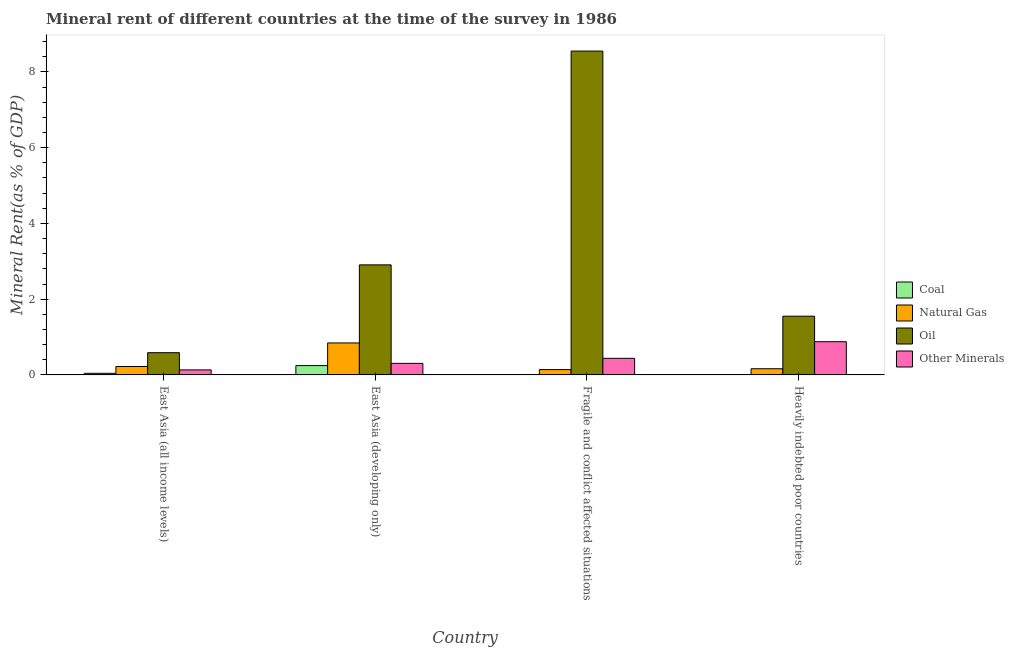Are the number of bars per tick equal to the number of legend labels?
Keep it short and to the point. Yes. Are the number of bars on each tick of the X-axis equal?
Your answer should be compact. Yes. How many bars are there on the 3rd tick from the left?
Provide a succinct answer. 4. How many bars are there on the 4th tick from the right?
Make the answer very short. 4. What is the label of the 4th group of bars from the left?
Your response must be concise. Heavily indebted poor countries. In how many cases, is the number of bars for a given country not equal to the number of legend labels?
Give a very brief answer. 0. What is the  rent of other minerals in Heavily indebted poor countries?
Give a very brief answer. 0.88. Across all countries, what is the maximum  rent of other minerals?
Keep it short and to the point. 0.88. Across all countries, what is the minimum oil rent?
Offer a terse response. 0.59. In which country was the oil rent maximum?
Your answer should be very brief. Fragile and conflict affected situations. In which country was the coal rent minimum?
Provide a short and direct response. Heavily indebted poor countries. What is the total  rent of other minerals in the graph?
Give a very brief answer. 1.75. What is the difference between the coal rent in East Asia (all income levels) and that in Heavily indebted poor countries?
Make the answer very short. 0.04. What is the difference between the  rent of other minerals in East Asia (all income levels) and the oil rent in Heavily indebted poor countries?
Make the answer very short. -1.42. What is the average oil rent per country?
Offer a terse response. 3.4. What is the difference between the natural gas rent and coal rent in Fragile and conflict affected situations?
Keep it short and to the point. 0.13. What is the ratio of the natural gas rent in East Asia (developing only) to that in Heavily indebted poor countries?
Keep it short and to the point. 5.18. Is the  rent of other minerals in East Asia (all income levels) less than that in Heavily indebted poor countries?
Offer a terse response. Yes. What is the difference between the highest and the second highest oil rent?
Your answer should be very brief. 5.64. What is the difference between the highest and the lowest coal rent?
Provide a succinct answer. 0.24. Is it the case that in every country, the sum of the oil rent and coal rent is greater than the sum of natural gas rent and  rent of other minerals?
Ensure brevity in your answer.  Yes. What does the 1st bar from the left in East Asia (developing only) represents?
Offer a terse response. Coal. What does the 1st bar from the right in Fragile and conflict affected situations represents?
Provide a succinct answer. Other Minerals. Are all the bars in the graph horizontal?
Give a very brief answer. No. Where does the legend appear in the graph?
Offer a terse response. Center right. How many legend labels are there?
Offer a very short reply. 4. What is the title of the graph?
Keep it short and to the point. Mineral rent of different countries at the time of the survey in 1986. Does "Secondary general education" appear as one of the legend labels in the graph?
Offer a very short reply. No. What is the label or title of the Y-axis?
Your answer should be very brief. Mineral Rent(as % of GDP). What is the Mineral Rent(as % of GDP) in Coal in East Asia (all income levels)?
Offer a terse response. 0.04. What is the Mineral Rent(as % of GDP) of Natural Gas in East Asia (all income levels)?
Keep it short and to the point. 0.22. What is the Mineral Rent(as % of GDP) in Oil in East Asia (all income levels)?
Provide a short and direct response. 0.59. What is the Mineral Rent(as % of GDP) in Other Minerals in East Asia (all income levels)?
Make the answer very short. 0.13. What is the Mineral Rent(as % of GDP) in Coal in East Asia (developing only)?
Give a very brief answer. 0.25. What is the Mineral Rent(as % of GDP) in Natural Gas in East Asia (developing only)?
Ensure brevity in your answer.  0.84. What is the Mineral Rent(as % of GDP) of Oil in East Asia (developing only)?
Your response must be concise. 2.91. What is the Mineral Rent(as % of GDP) of Other Minerals in East Asia (developing only)?
Your answer should be compact. 0.3. What is the Mineral Rent(as % of GDP) of Coal in Fragile and conflict affected situations?
Offer a very short reply. 0.01. What is the Mineral Rent(as % of GDP) of Natural Gas in Fragile and conflict affected situations?
Provide a short and direct response. 0.14. What is the Mineral Rent(as % of GDP) of Oil in Fragile and conflict affected situations?
Offer a very short reply. 8.55. What is the Mineral Rent(as % of GDP) in Other Minerals in Fragile and conflict affected situations?
Offer a terse response. 0.44. What is the Mineral Rent(as % of GDP) of Coal in Heavily indebted poor countries?
Your response must be concise. 0. What is the Mineral Rent(as % of GDP) in Natural Gas in Heavily indebted poor countries?
Provide a succinct answer. 0.16. What is the Mineral Rent(as % of GDP) of Oil in Heavily indebted poor countries?
Provide a short and direct response. 1.55. What is the Mineral Rent(as % of GDP) of Other Minerals in Heavily indebted poor countries?
Keep it short and to the point. 0.88. Across all countries, what is the maximum Mineral Rent(as % of GDP) of Coal?
Your response must be concise. 0.25. Across all countries, what is the maximum Mineral Rent(as % of GDP) in Natural Gas?
Offer a very short reply. 0.84. Across all countries, what is the maximum Mineral Rent(as % of GDP) of Oil?
Keep it short and to the point. 8.55. Across all countries, what is the maximum Mineral Rent(as % of GDP) in Other Minerals?
Make the answer very short. 0.88. Across all countries, what is the minimum Mineral Rent(as % of GDP) in Coal?
Provide a short and direct response. 0. Across all countries, what is the minimum Mineral Rent(as % of GDP) in Natural Gas?
Keep it short and to the point. 0.14. Across all countries, what is the minimum Mineral Rent(as % of GDP) in Oil?
Provide a succinct answer. 0.59. Across all countries, what is the minimum Mineral Rent(as % of GDP) of Other Minerals?
Give a very brief answer. 0.13. What is the total Mineral Rent(as % of GDP) of Coal in the graph?
Provide a succinct answer. 0.3. What is the total Mineral Rent(as % of GDP) in Natural Gas in the graph?
Offer a terse response. 1.37. What is the total Mineral Rent(as % of GDP) of Oil in the graph?
Provide a succinct answer. 13.59. What is the total Mineral Rent(as % of GDP) in Other Minerals in the graph?
Provide a succinct answer. 1.75. What is the difference between the Mineral Rent(as % of GDP) of Coal in East Asia (all income levels) and that in East Asia (developing only)?
Offer a terse response. -0.2. What is the difference between the Mineral Rent(as % of GDP) of Natural Gas in East Asia (all income levels) and that in East Asia (developing only)?
Give a very brief answer. -0.62. What is the difference between the Mineral Rent(as % of GDP) in Oil in East Asia (all income levels) and that in East Asia (developing only)?
Offer a very short reply. -2.32. What is the difference between the Mineral Rent(as % of GDP) in Other Minerals in East Asia (all income levels) and that in East Asia (developing only)?
Give a very brief answer. -0.17. What is the difference between the Mineral Rent(as % of GDP) in Coal in East Asia (all income levels) and that in Fragile and conflict affected situations?
Your answer should be very brief. 0.03. What is the difference between the Mineral Rent(as % of GDP) in Natural Gas in East Asia (all income levels) and that in Fragile and conflict affected situations?
Make the answer very short. 0.08. What is the difference between the Mineral Rent(as % of GDP) of Oil in East Asia (all income levels) and that in Fragile and conflict affected situations?
Your answer should be very brief. -7.96. What is the difference between the Mineral Rent(as % of GDP) of Other Minerals in East Asia (all income levels) and that in Fragile and conflict affected situations?
Offer a terse response. -0.31. What is the difference between the Mineral Rent(as % of GDP) in Coal in East Asia (all income levels) and that in Heavily indebted poor countries?
Keep it short and to the point. 0.04. What is the difference between the Mineral Rent(as % of GDP) in Natural Gas in East Asia (all income levels) and that in Heavily indebted poor countries?
Your answer should be compact. 0.06. What is the difference between the Mineral Rent(as % of GDP) in Oil in East Asia (all income levels) and that in Heavily indebted poor countries?
Your answer should be very brief. -0.96. What is the difference between the Mineral Rent(as % of GDP) of Other Minerals in East Asia (all income levels) and that in Heavily indebted poor countries?
Your answer should be very brief. -0.74. What is the difference between the Mineral Rent(as % of GDP) of Coal in East Asia (developing only) and that in Fragile and conflict affected situations?
Provide a succinct answer. 0.24. What is the difference between the Mineral Rent(as % of GDP) of Natural Gas in East Asia (developing only) and that in Fragile and conflict affected situations?
Your answer should be compact. 0.7. What is the difference between the Mineral Rent(as % of GDP) in Oil in East Asia (developing only) and that in Fragile and conflict affected situations?
Offer a very short reply. -5.64. What is the difference between the Mineral Rent(as % of GDP) of Other Minerals in East Asia (developing only) and that in Fragile and conflict affected situations?
Provide a succinct answer. -0.13. What is the difference between the Mineral Rent(as % of GDP) of Coal in East Asia (developing only) and that in Heavily indebted poor countries?
Your answer should be very brief. 0.24. What is the difference between the Mineral Rent(as % of GDP) in Natural Gas in East Asia (developing only) and that in Heavily indebted poor countries?
Provide a short and direct response. 0.68. What is the difference between the Mineral Rent(as % of GDP) of Oil in East Asia (developing only) and that in Heavily indebted poor countries?
Your answer should be very brief. 1.35. What is the difference between the Mineral Rent(as % of GDP) in Other Minerals in East Asia (developing only) and that in Heavily indebted poor countries?
Provide a short and direct response. -0.57. What is the difference between the Mineral Rent(as % of GDP) of Coal in Fragile and conflict affected situations and that in Heavily indebted poor countries?
Give a very brief answer. 0.01. What is the difference between the Mineral Rent(as % of GDP) in Natural Gas in Fragile and conflict affected situations and that in Heavily indebted poor countries?
Your answer should be very brief. -0.02. What is the difference between the Mineral Rent(as % of GDP) in Oil in Fragile and conflict affected situations and that in Heavily indebted poor countries?
Make the answer very short. 7. What is the difference between the Mineral Rent(as % of GDP) in Other Minerals in Fragile and conflict affected situations and that in Heavily indebted poor countries?
Offer a very short reply. -0.44. What is the difference between the Mineral Rent(as % of GDP) in Coal in East Asia (all income levels) and the Mineral Rent(as % of GDP) in Natural Gas in East Asia (developing only)?
Give a very brief answer. -0.8. What is the difference between the Mineral Rent(as % of GDP) in Coal in East Asia (all income levels) and the Mineral Rent(as % of GDP) in Oil in East Asia (developing only)?
Keep it short and to the point. -2.86. What is the difference between the Mineral Rent(as % of GDP) of Coal in East Asia (all income levels) and the Mineral Rent(as % of GDP) of Other Minerals in East Asia (developing only)?
Your answer should be compact. -0.26. What is the difference between the Mineral Rent(as % of GDP) of Natural Gas in East Asia (all income levels) and the Mineral Rent(as % of GDP) of Oil in East Asia (developing only)?
Provide a short and direct response. -2.68. What is the difference between the Mineral Rent(as % of GDP) of Natural Gas in East Asia (all income levels) and the Mineral Rent(as % of GDP) of Other Minerals in East Asia (developing only)?
Your answer should be very brief. -0.08. What is the difference between the Mineral Rent(as % of GDP) of Oil in East Asia (all income levels) and the Mineral Rent(as % of GDP) of Other Minerals in East Asia (developing only)?
Your answer should be compact. 0.28. What is the difference between the Mineral Rent(as % of GDP) of Coal in East Asia (all income levels) and the Mineral Rent(as % of GDP) of Natural Gas in Fragile and conflict affected situations?
Offer a terse response. -0.1. What is the difference between the Mineral Rent(as % of GDP) of Coal in East Asia (all income levels) and the Mineral Rent(as % of GDP) of Oil in Fragile and conflict affected situations?
Your answer should be compact. -8.51. What is the difference between the Mineral Rent(as % of GDP) of Coal in East Asia (all income levels) and the Mineral Rent(as % of GDP) of Other Minerals in Fragile and conflict affected situations?
Make the answer very short. -0.4. What is the difference between the Mineral Rent(as % of GDP) in Natural Gas in East Asia (all income levels) and the Mineral Rent(as % of GDP) in Oil in Fragile and conflict affected situations?
Your answer should be very brief. -8.33. What is the difference between the Mineral Rent(as % of GDP) in Natural Gas in East Asia (all income levels) and the Mineral Rent(as % of GDP) in Other Minerals in Fragile and conflict affected situations?
Ensure brevity in your answer.  -0.22. What is the difference between the Mineral Rent(as % of GDP) of Oil in East Asia (all income levels) and the Mineral Rent(as % of GDP) of Other Minerals in Fragile and conflict affected situations?
Give a very brief answer. 0.15. What is the difference between the Mineral Rent(as % of GDP) in Coal in East Asia (all income levels) and the Mineral Rent(as % of GDP) in Natural Gas in Heavily indebted poor countries?
Provide a succinct answer. -0.12. What is the difference between the Mineral Rent(as % of GDP) in Coal in East Asia (all income levels) and the Mineral Rent(as % of GDP) in Oil in Heavily indebted poor countries?
Provide a succinct answer. -1.51. What is the difference between the Mineral Rent(as % of GDP) in Coal in East Asia (all income levels) and the Mineral Rent(as % of GDP) in Other Minerals in Heavily indebted poor countries?
Give a very brief answer. -0.83. What is the difference between the Mineral Rent(as % of GDP) in Natural Gas in East Asia (all income levels) and the Mineral Rent(as % of GDP) in Oil in Heavily indebted poor countries?
Offer a very short reply. -1.33. What is the difference between the Mineral Rent(as % of GDP) in Natural Gas in East Asia (all income levels) and the Mineral Rent(as % of GDP) in Other Minerals in Heavily indebted poor countries?
Provide a succinct answer. -0.65. What is the difference between the Mineral Rent(as % of GDP) of Oil in East Asia (all income levels) and the Mineral Rent(as % of GDP) of Other Minerals in Heavily indebted poor countries?
Provide a short and direct response. -0.29. What is the difference between the Mineral Rent(as % of GDP) of Coal in East Asia (developing only) and the Mineral Rent(as % of GDP) of Natural Gas in Fragile and conflict affected situations?
Your answer should be compact. 0.1. What is the difference between the Mineral Rent(as % of GDP) of Coal in East Asia (developing only) and the Mineral Rent(as % of GDP) of Oil in Fragile and conflict affected situations?
Ensure brevity in your answer.  -8.3. What is the difference between the Mineral Rent(as % of GDP) of Coal in East Asia (developing only) and the Mineral Rent(as % of GDP) of Other Minerals in Fragile and conflict affected situations?
Make the answer very short. -0.19. What is the difference between the Mineral Rent(as % of GDP) in Natural Gas in East Asia (developing only) and the Mineral Rent(as % of GDP) in Oil in Fragile and conflict affected situations?
Your answer should be very brief. -7.71. What is the difference between the Mineral Rent(as % of GDP) in Natural Gas in East Asia (developing only) and the Mineral Rent(as % of GDP) in Other Minerals in Fragile and conflict affected situations?
Provide a short and direct response. 0.41. What is the difference between the Mineral Rent(as % of GDP) in Oil in East Asia (developing only) and the Mineral Rent(as % of GDP) in Other Minerals in Fragile and conflict affected situations?
Keep it short and to the point. 2.47. What is the difference between the Mineral Rent(as % of GDP) of Coal in East Asia (developing only) and the Mineral Rent(as % of GDP) of Natural Gas in Heavily indebted poor countries?
Keep it short and to the point. 0.08. What is the difference between the Mineral Rent(as % of GDP) of Coal in East Asia (developing only) and the Mineral Rent(as % of GDP) of Oil in Heavily indebted poor countries?
Provide a succinct answer. -1.3. What is the difference between the Mineral Rent(as % of GDP) of Coal in East Asia (developing only) and the Mineral Rent(as % of GDP) of Other Minerals in Heavily indebted poor countries?
Provide a succinct answer. -0.63. What is the difference between the Mineral Rent(as % of GDP) of Natural Gas in East Asia (developing only) and the Mineral Rent(as % of GDP) of Oil in Heavily indebted poor countries?
Keep it short and to the point. -0.71. What is the difference between the Mineral Rent(as % of GDP) in Natural Gas in East Asia (developing only) and the Mineral Rent(as % of GDP) in Other Minerals in Heavily indebted poor countries?
Offer a very short reply. -0.03. What is the difference between the Mineral Rent(as % of GDP) in Oil in East Asia (developing only) and the Mineral Rent(as % of GDP) in Other Minerals in Heavily indebted poor countries?
Make the answer very short. 2.03. What is the difference between the Mineral Rent(as % of GDP) of Coal in Fragile and conflict affected situations and the Mineral Rent(as % of GDP) of Natural Gas in Heavily indebted poor countries?
Make the answer very short. -0.15. What is the difference between the Mineral Rent(as % of GDP) in Coal in Fragile and conflict affected situations and the Mineral Rent(as % of GDP) in Oil in Heavily indebted poor countries?
Offer a terse response. -1.54. What is the difference between the Mineral Rent(as % of GDP) of Coal in Fragile and conflict affected situations and the Mineral Rent(as % of GDP) of Other Minerals in Heavily indebted poor countries?
Your answer should be compact. -0.87. What is the difference between the Mineral Rent(as % of GDP) of Natural Gas in Fragile and conflict affected situations and the Mineral Rent(as % of GDP) of Oil in Heavily indebted poor countries?
Offer a very short reply. -1.41. What is the difference between the Mineral Rent(as % of GDP) of Natural Gas in Fragile and conflict affected situations and the Mineral Rent(as % of GDP) of Other Minerals in Heavily indebted poor countries?
Provide a succinct answer. -0.74. What is the difference between the Mineral Rent(as % of GDP) of Oil in Fragile and conflict affected situations and the Mineral Rent(as % of GDP) of Other Minerals in Heavily indebted poor countries?
Offer a very short reply. 7.67. What is the average Mineral Rent(as % of GDP) of Coal per country?
Provide a succinct answer. 0.07. What is the average Mineral Rent(as % of GDP) in Natural Gas per country?
Keep it short and to the point. 0.34. What is the average Mineral Rent(as % of GDP) of Oil per country?
Your answer should be compact. 3.4. What is the average Mineral Rent(as % of GDP) in Other Minerals per country?
Give a very brief answer. 0.44. What is the difference between the Mineral Rent(as % of GDP) in Coal and Mineral Rent(as % of GDP) in Natural Gas in East Asia (all income levels)?
Provide a short and direct response. -0.18. What is the difference between the Mineral Rent(as % of GDP) of Coal and Mineral Rent(as % of GDP) of Oil in East Asia (all income levels)?
Offer a terse response. -0.54. What is the difference between the Mineral Rent(as % of GDP) of Coal and Mineral Rent(as % of GDP) of Other Minerals in East Asia (all income levels)?
Ensure brevity in your answer.  -0.09. What is the difference between the Mineral Rent(as % of GDP) of Natural Gas and Mineral Rent(as % of GDP) of Oil in East Asia (all income levels)?
Your answer should be compact. -0.36. What is the difference between the Mineral Rent(as % of GDP) in Natural Gas and Mineral Rent(as % of GDP) in Other Minerals in East Asia (all income levels)?
Your response must be concise. 0.09. What is the difference between the Mineral Rent(as % of GDP) in Oil and Mineral Rent(as % of GDP) in Other Minerals in East Asia (all income levels)?
Make the answer very short. 0.45. What is the difference between the Mineral Rent(as % of GDP) in Coal and Mineral Rent(as % of GDP) in Natural Gas in East Asia (developing only)?
Your response must be concise. -0.6. What is the difference between the Mineral Rent(as % of GDP) in Coal and Mineral Rent(as % of GDP) in Oil in East Asia (developing only)?
Provide a succinct answer. -2.66. What is the difference between the Mineral Rent(as % of GDP) of Coal and Mineral Rent(as % of GDP) of Other Minerals in East Asia (developing only)?
Your answer should be very brief. -0.06. What is the difference between the Mineral Rent(as % of GDP) in Natural Gas and Mineral Rent(as % of GDP) in Oil in East Asia (developing only)?
Provide a short and direct response. -2.06. What is the difference between the Mineral Rent(as % of GDP) in Natural Gas and Mineral Rent(as % of GDP) in Other Minerals in East Asia (developing only)?
Provide a short and direct response. 0.54. What is the difference between the Mineral Rent(as % of GDP) in Oil and Mineral Rent(as % of GDP) in Other Minerals in East Asia (developing only)?
Your answer should be very brief. 2.6. What is the difference between the Mineral Rent(as % of GDP) in Coal and Mineral Rent(as % of GDP) in Natural Gas in Fragile and conflict affected situations?
Give a very brief answer. -0.13. What is the difference between the Mineral Rent(as % of GDP) of Coal and Mineral Rent(as % of GDP) of Oil in Fragile and conflict affected situations?
Ensure brevity in your answer.  -8.54. What is the difference between the Mineral Rent(as % of GDP) in Coal and Mineral Rent(as % of GDP) in Other Minerals in Fragile and conflict affected situations?
Your response must be concise. -0.43. What is the difference between the Mineral Rent(as % of GDP) of Natural Gas and Mineral Rent(as % of GDP) of Oil in Fragile and conflict affected situations?
Provide a short and direct response. -8.41. What is the difference between the Mineral Rent(as % of GDP) in Natural Gas and Mineral Rent(as % of GDP) in Other Minerals in Fragile and conflict affected situations?
Keep it short and to the point. -0.3. What is the difference between the Mineral Rent(as % of GDP) of Oil and Mineral Rent(as % of GDP) of Other Minerals in Fragile and conflict affected situations?
Give a very brief answer. 8.11. What is the difference between the Mineral Rent(as % of GDP) of Coal and Mineral Rent(as % of GDP) of Natural Gas in Heavily indebted poor countries?
Provide a short and direct response. -0.16. What is the difference between the Mineral Rent(as % of GDP) in Coal and Mineral Rent(as % of GDP) in Oil in Heavily indebted poor countries?
Keep it short and to the point. -1.55. What is the difference between the Mineral Rent(as % of GDP) in Coal and Mineral Rent(as % of GDP) in Other Minerals in Heavily indebted poor countries?
Make the answer very short. -0.88. What is the difference between the Mineral Rent(as % of GDP) of Natural Gas and Mineral Rent(as % of GDP) of Oil in Heavily indebted poor countries?
Provide a succinct answer. -1.39. What is the difference between the Mineral Rent(as % of GDP) in Natural Gas and Mineral Rent(as % of GDP) in Other Minerals in Heavily indebted poor countries?
Offer a very short reply. -0.71. What is the difference between the Mineral Rent(as % of GDP) in Oil and Mineral Rent(as % of GDP) in Other Minerals in Heavily indebted poor countries?
Ensure brevity in your answer.  0.67. What is the ratio of the Mineral Rent(as % of GDP) of Coal in East Asia (all income levels) to that in East Asia (developing only)?
Offer a very short reply. 0.17. What is the ratio of the Mineral Rent(as % of GDP) of Natural Gas in East Asia (all income levels) to that in East Asia (developing only)?
Offer a very short reply. 0.26. What is the ratio of the Mineral Rent(as % of GDP) of Oil in East Asia (all income levels) to that in East Asia (developing only)?
Provide a succinct answer. 0.2. What is the ratio of the Mineral Rent(as % of GDP) in Other Minerals in East Asia (all income levels) to that in East Asia (developing only)?
Give a very brief answer. 0.43. What is the ratio of the Mineral Rent(as % of GDP) of Coal in East Asia (all income levels) to that in Fragile and conflict affected situations?
Your answer should be very brief. 4.35. What is the ratio of the Mineral Rent(as % of GDP) of Natural Gas in East Asia (all income levels) to that in Fragile and conflict affected situations?
Provide a short and direct response. 1.58. What is the ratio of the Mineral Rent(as % of GDP) in Oil in East Asia (all income levels) to that in Fragile and conflict affected situations?
Offer a terse response. 0.07. What is the ratio of the Mineral Rent(as % of GDP) in Other Minerals in East Asia (all income levels) to that in Fragile and conflict affected situations?
Offer a terse response. 0.3. What is the ratio of the Mineral Rent(as % of GDP) of Coal in East Asia (all income levels) to that in Heavily indebted poor countries?
Keep it short and to the point. 29.91. What is the ratio of the Mineral Rent(as % of GDP) of Natural Gas in East Asia (all income levels) to that in Heavily indebted poor countries?
Keep it short and to the point. 1.36. What is the ratio of the Mineral Rent(as % of GDP) of Oil in East Asia (all income levels) to that in Heavily indebted poor countries?
Provide a succinct answer. 0.38. What is the ratio of the Mineral Rent(as % of GDP) in Other Minerals in East Asia (all income levels) to that in Heavily indebted poor countries?
Give a very brief answer. 0.15. What is the ratio of the Mineral Rent(as % of GDP) in Coal in East Asia (developing only) to that in Fragile and conflict affected situations?
Ensure brevity in your answer.  25.13. What is the ratio of the Mineral Rent(as % of GDP) of Natural Gas in East Asia (developing only) to that in Fragile and conflict affected situations?
Your answer should be very brief. 5.99. What is the ratio of the Mineral Rent(as % of GDP) of Oil in East Asia (developing only) to that in Fragile and conflict affected situations?
Offer a terse response. 0.34. What is the ratio of the Mineral Rent(as % of GDP) in Other Minerals in East Asia (developing only) to that in Fragile and conflict affected situations?
Provide a succinct answer. 0.7. What is the ratio of the Mineral Rent(as % of GDP) in Coal in East Asia (developing only) to that in Heavily indebted poor countries?
Provide a short and direct response. 172.68. What is the ratio of the Mineral Rent(as % of GDP) of Natural Gas in East Asia (developing only) to that in Heavily indebted poor countries?
Give a very brief answer. 5.18. What is the ratio of the Mineral Rent(as % of GDP) of Oil in East Asia (developing only) to that in Heavily indebted poor countries?
Offer a very short reply. 1.87. What is the ratio of the Mineral Rent(as % of GDP) in Other Minerals in East Asia (developing only) to that in Heavily indebted poor countries?
Your response must be concise. 0.35. What is the ratio of the Mineral Rent(as % of GDP) in Coal in Fragile and conflict affected situations to that in Heavily indebted poor countries?
Offer a very short reply. 6.87. What is the ratio of the Mineral Rent(as % of GDP) in Natural Gas in Fragile and conflict affected situations to that in Heavily indebted poor countries?
Offer a terse response. 0.86. What is the ratio of the Mineral Rent(as % of GDP) in Oil in Fragile and conflict affected situations to that in Heavily indebted poor countries?
Provide a succinct answer. 5.51. What is the ratio of the Mineral Rent(as % of GDP) in Other Minerals in Fragile and conflict affected situations to that in Heavily indebted poor countries?
Provide a short and direct response. 0.5. What is the difference between the highest and the second highest Mineral Rent(as % of GDP) in Coal?
Your answer should be compact. 0.2. What is the difference between the highest and the second highest Mineral Rent(as % of GDP) in Natural Gas?
Provide a short and direct response. 0.62. What is the difference between the highest and the second highest Mineral Rent(as % of GDP) in Oil?
Make the answer very short. 5.64. What is the difference between the highest and the second highest Mineral Rent(as % of GDP) in Other Minerals?
Offer a terse response. 0.44. What is the difference between the highest and the lowest Mineral Rent(as % of GDP) of Coal?
Make the answer very short. 0.24. What is the difference between the highest and the lowest Mineral Rent(as % of GDP) of Natural Gas?
Your response must be concise. 0.7. What is the difference between the highest and the lowest Mineral Rent(as % of GDP) of Oil?
Your answer should be compact. 7.96. What is the difference between the highest and the lowest Mineral Rent(as % of GDP) of Other Minerals?
Give a very brief answer. 0.74. 